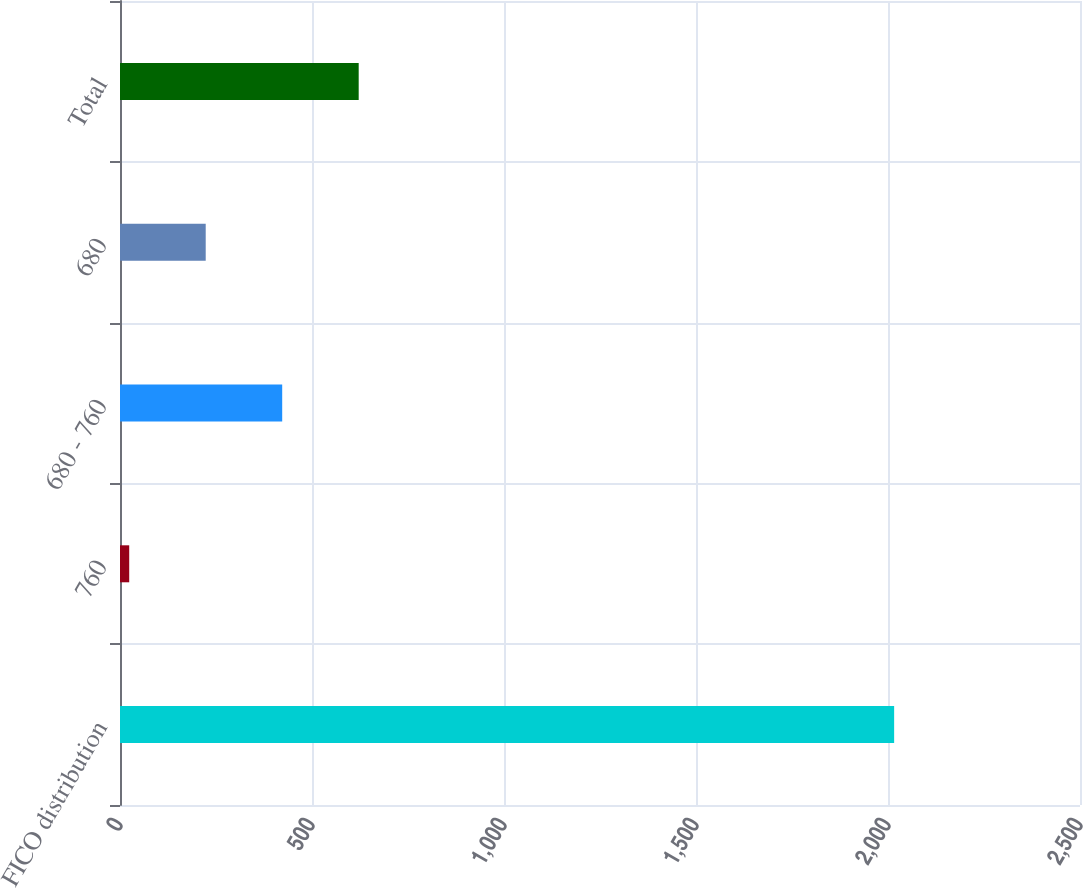<chart> <loc_0><loc_0><loc_500><loc_500><bar_chart><fcel>FICO distribution<fcel>760<fcel>680 - 760<fcel>680<fcel>Total<nl><fcel>2016<fcel>24<fcel>422.4<fcel>223.2<fcel>621.6<nl></chart> 